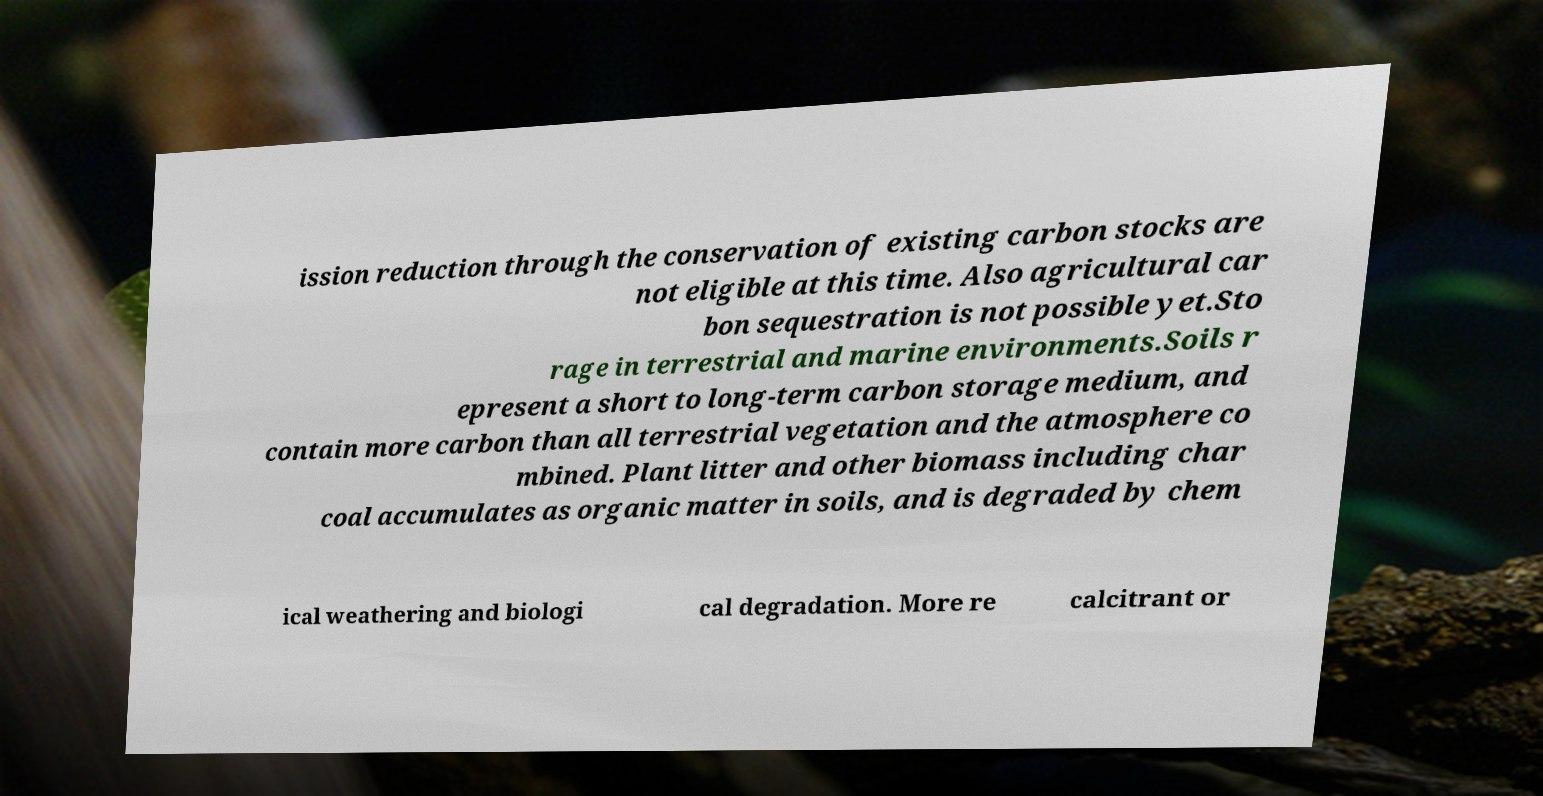Can you accurately transcribe the text from the provided image for me? ission reduction through the conservation of existing carbon stocks are not eligible at this time. Also agricultural car bon sequestration is not possible yet.Sto rage in terrestrial and marine environments.Soils r epresent a short to long-term carbon storage medium, and contain more carbon than all terrestrial vegetation and the atmosphere co mbined. Plant litter and other biomass including char coal accumulates as organic matter in soils, and is degraded by chem ical weathering and biologi cal degradation. More re calcitrant or 